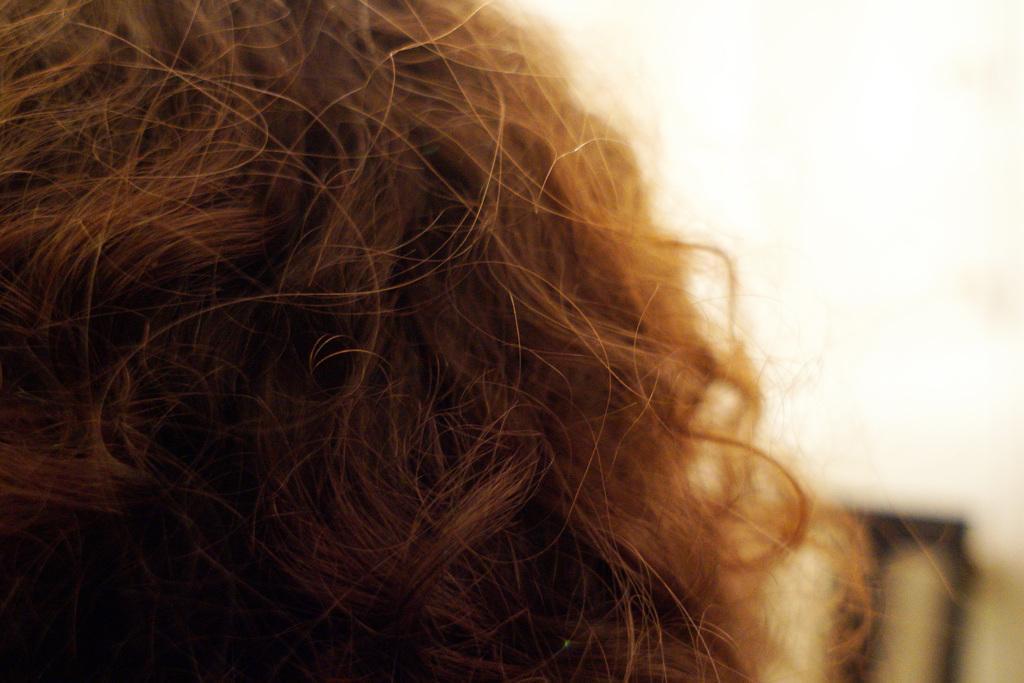Can you describe this image briefly? On the left side, there is a hair of a person. In the background, there is an object. And the background is white in color. 